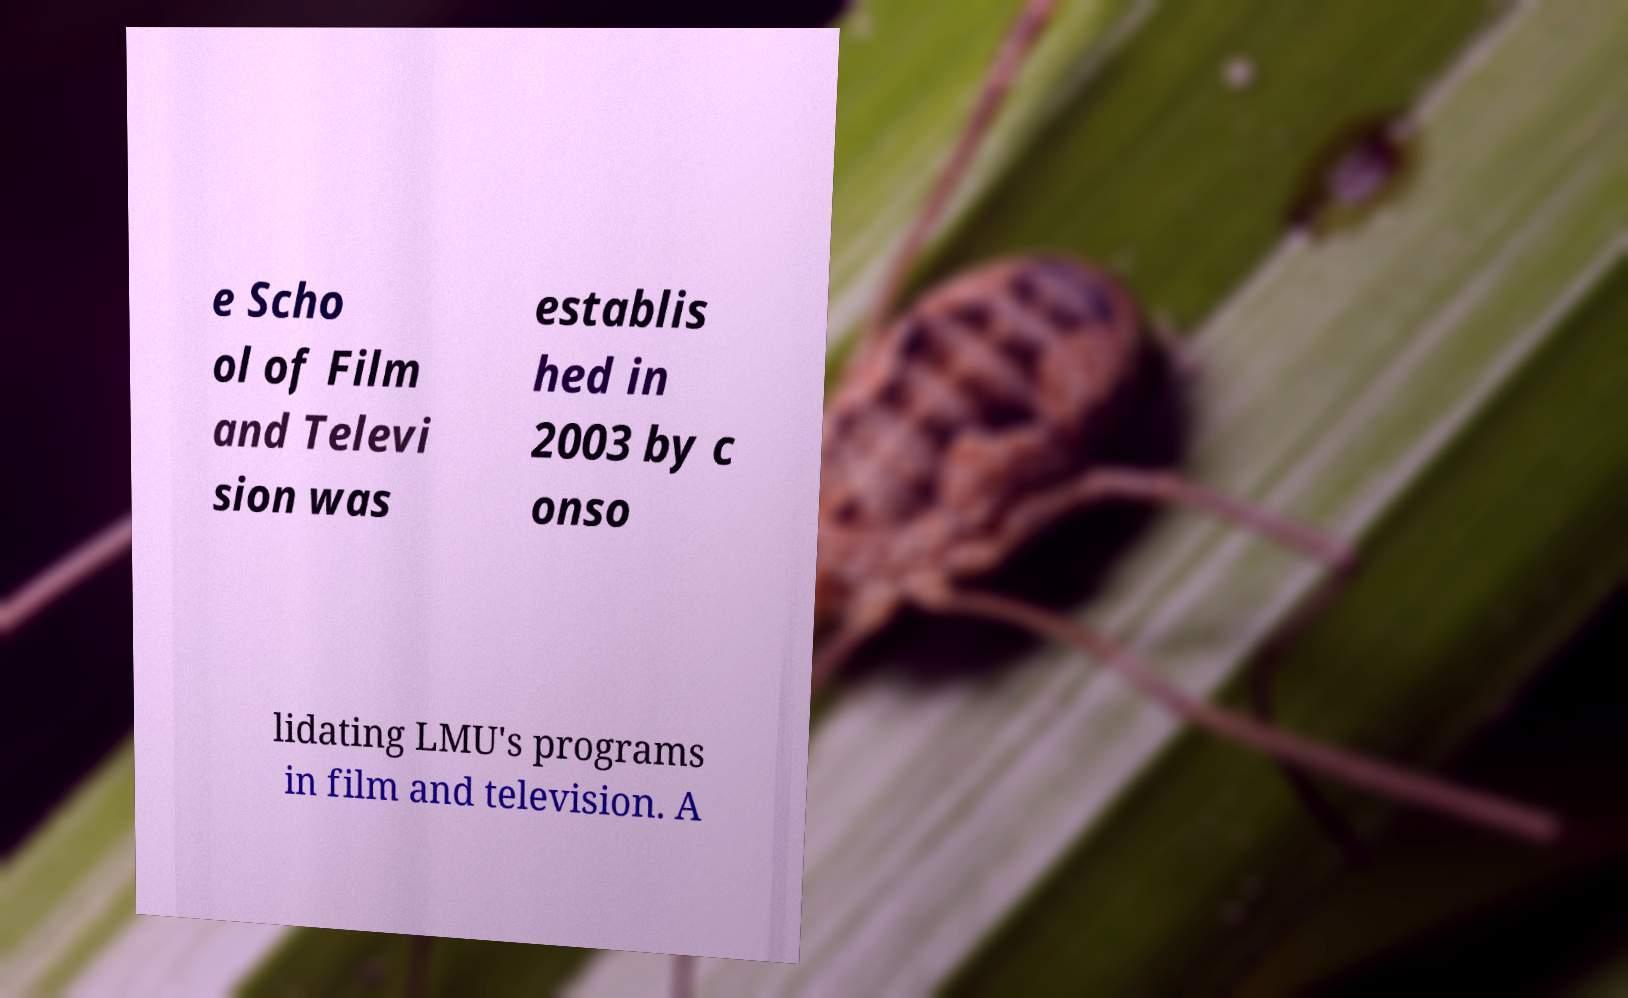What messages or text are displayed in this image? I need them in a readable, typed format. e Scho ol of Film and Televi sion was establis hed in 2003 by c onso lidating LMU's programs in film and television. A 